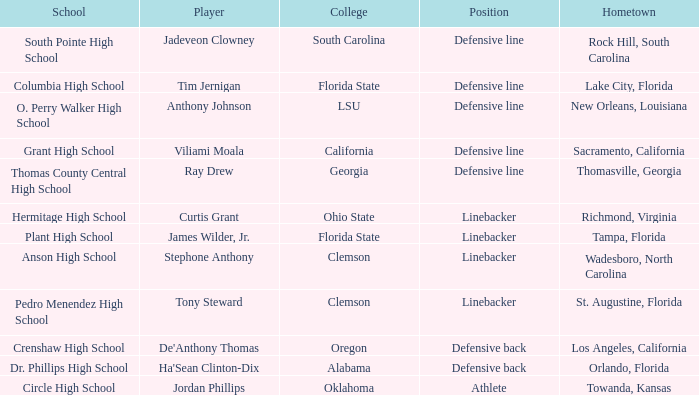Which hometown has a player of Ray Drew? Thomasville, Georgia. 